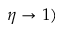<formula> <loc_0><loc_0><loc_500><loc_500>\eta \rightarrow 1 )</formula> 